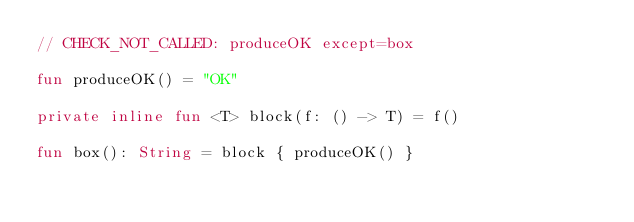<code> <loc_0><loc_0><loc_500><loc_500><_Kotlin_>// CHECK_NOT_CALLED: produceOK except=box

fun produceOK() = "OK"

private inline fun <T> block(f: () -> T) = f()

fun box(): String = block { produceOK() }</code> 